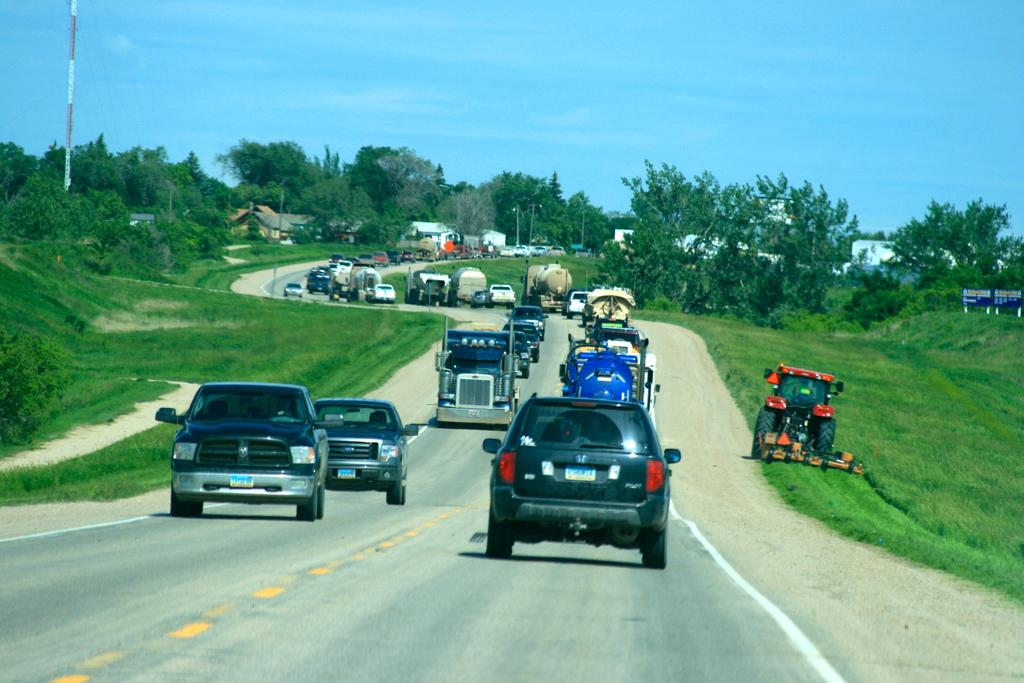What can be seen on the road in the image? There are vehicles on the road in the image. What type of natural elements are present in the image? There are trees and grass in the image. What man-made structures can be seen in the image? There are poles, buildings, and boards with text in the image. What is visible in the background of the image? The sky with clouds is visible in the background of the image. What effect does the top have on the idea in the image? There is no top or idea present in the image; the image features vehicles on the road, trees, poles, buildings, grass, boards with text, and the sky with clouds. 